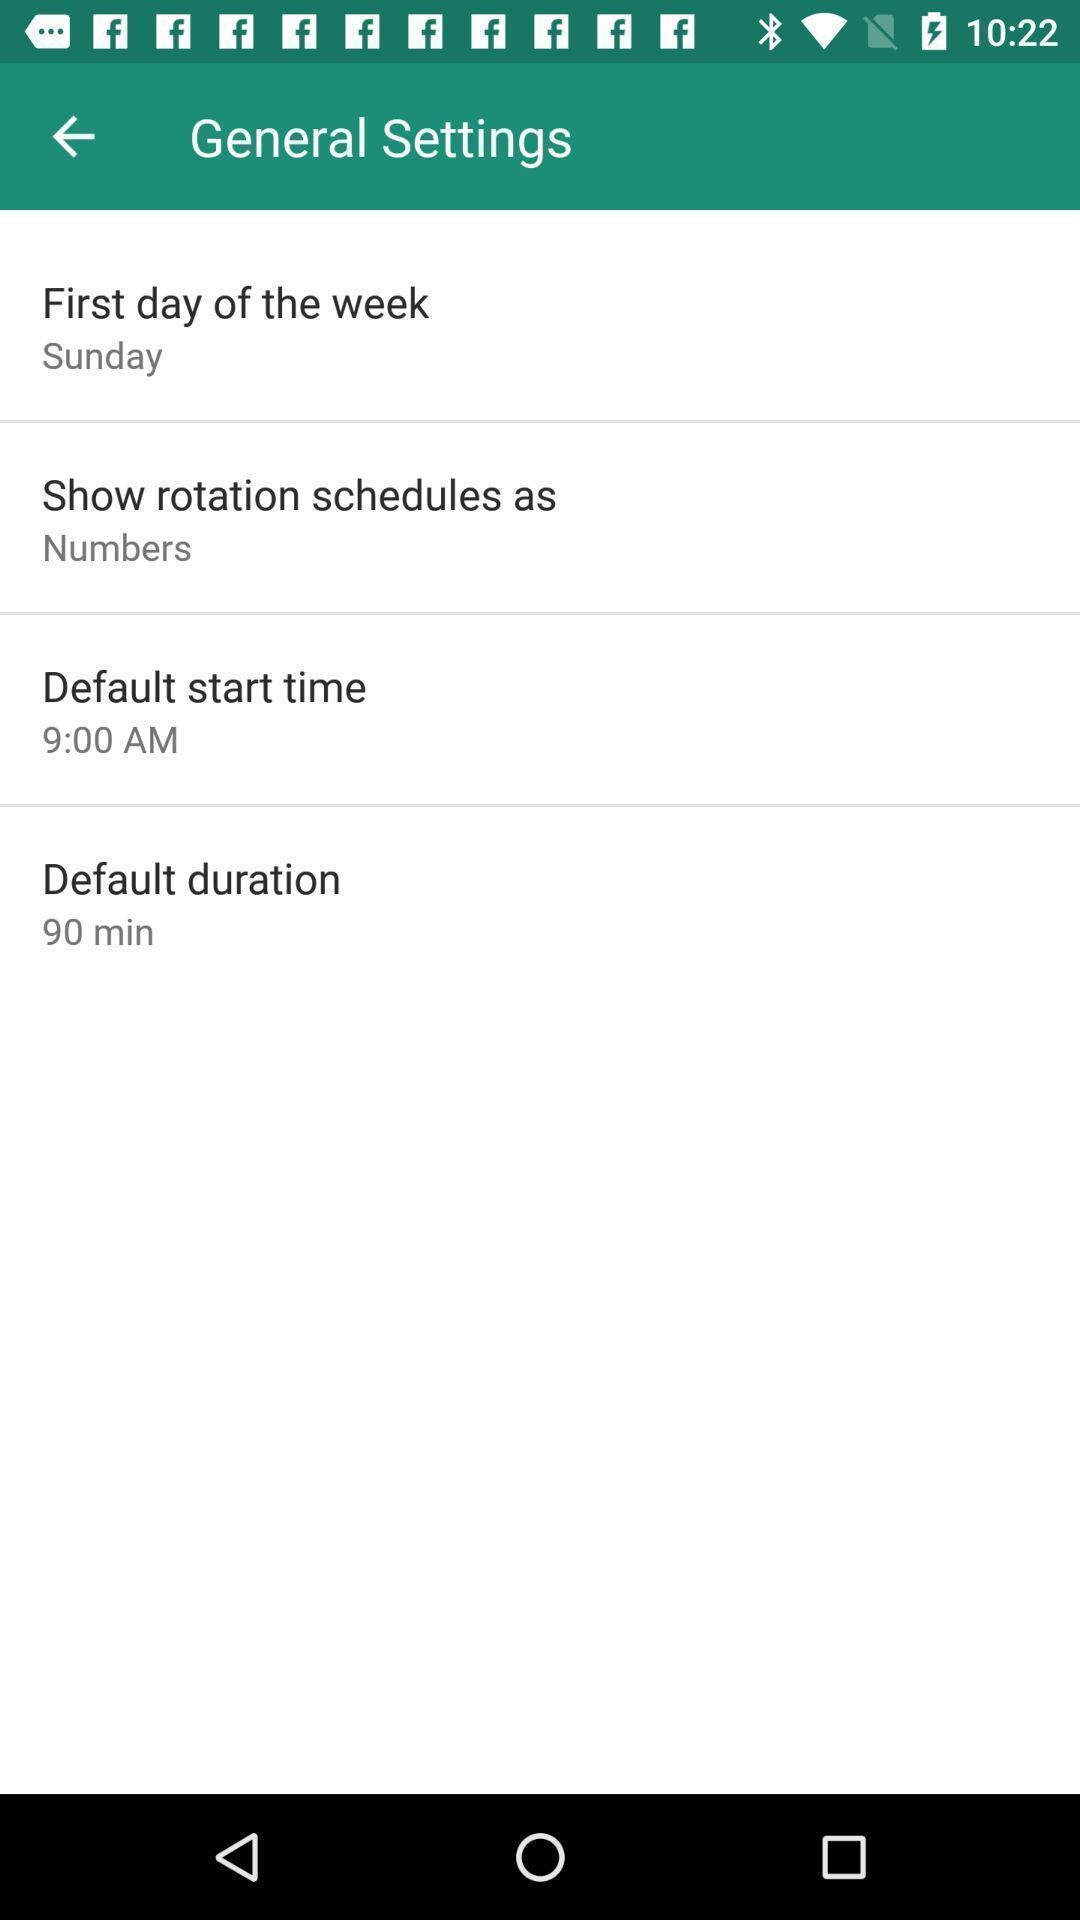Please provide a description for this image. Settings page. 